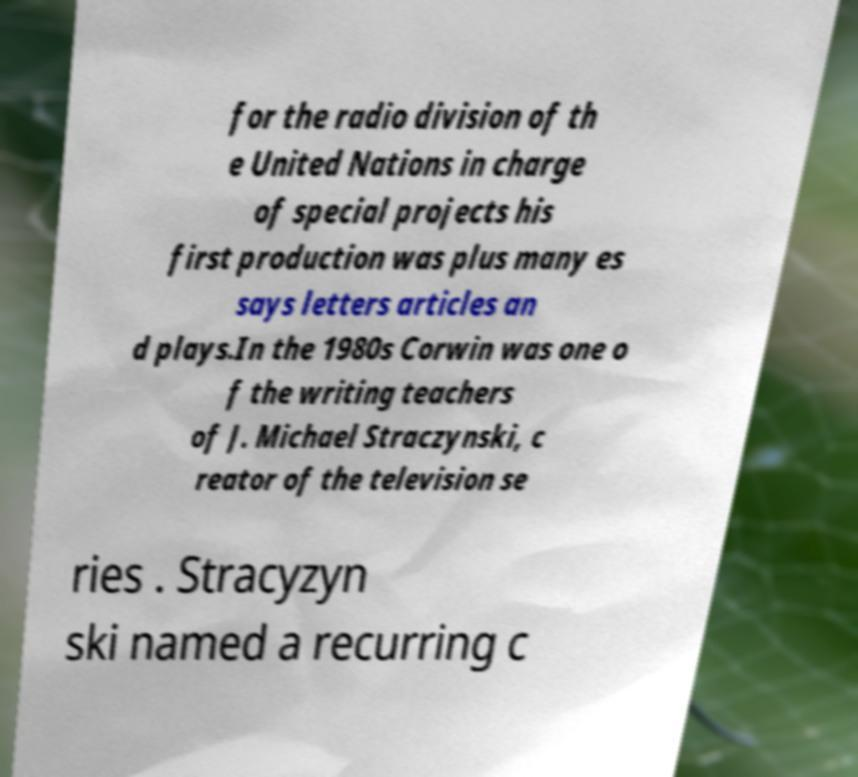Please identify and transcribe the text found in this image. for the radio division of th e United Nations in charge of special projects his first production was plus many es says letters articles an d plays.In the 1980s Corwin was one o f the writing teachers of J. Michael Straczynski, c reator of the television se ries . Stracyzyn ski named a recurring c 